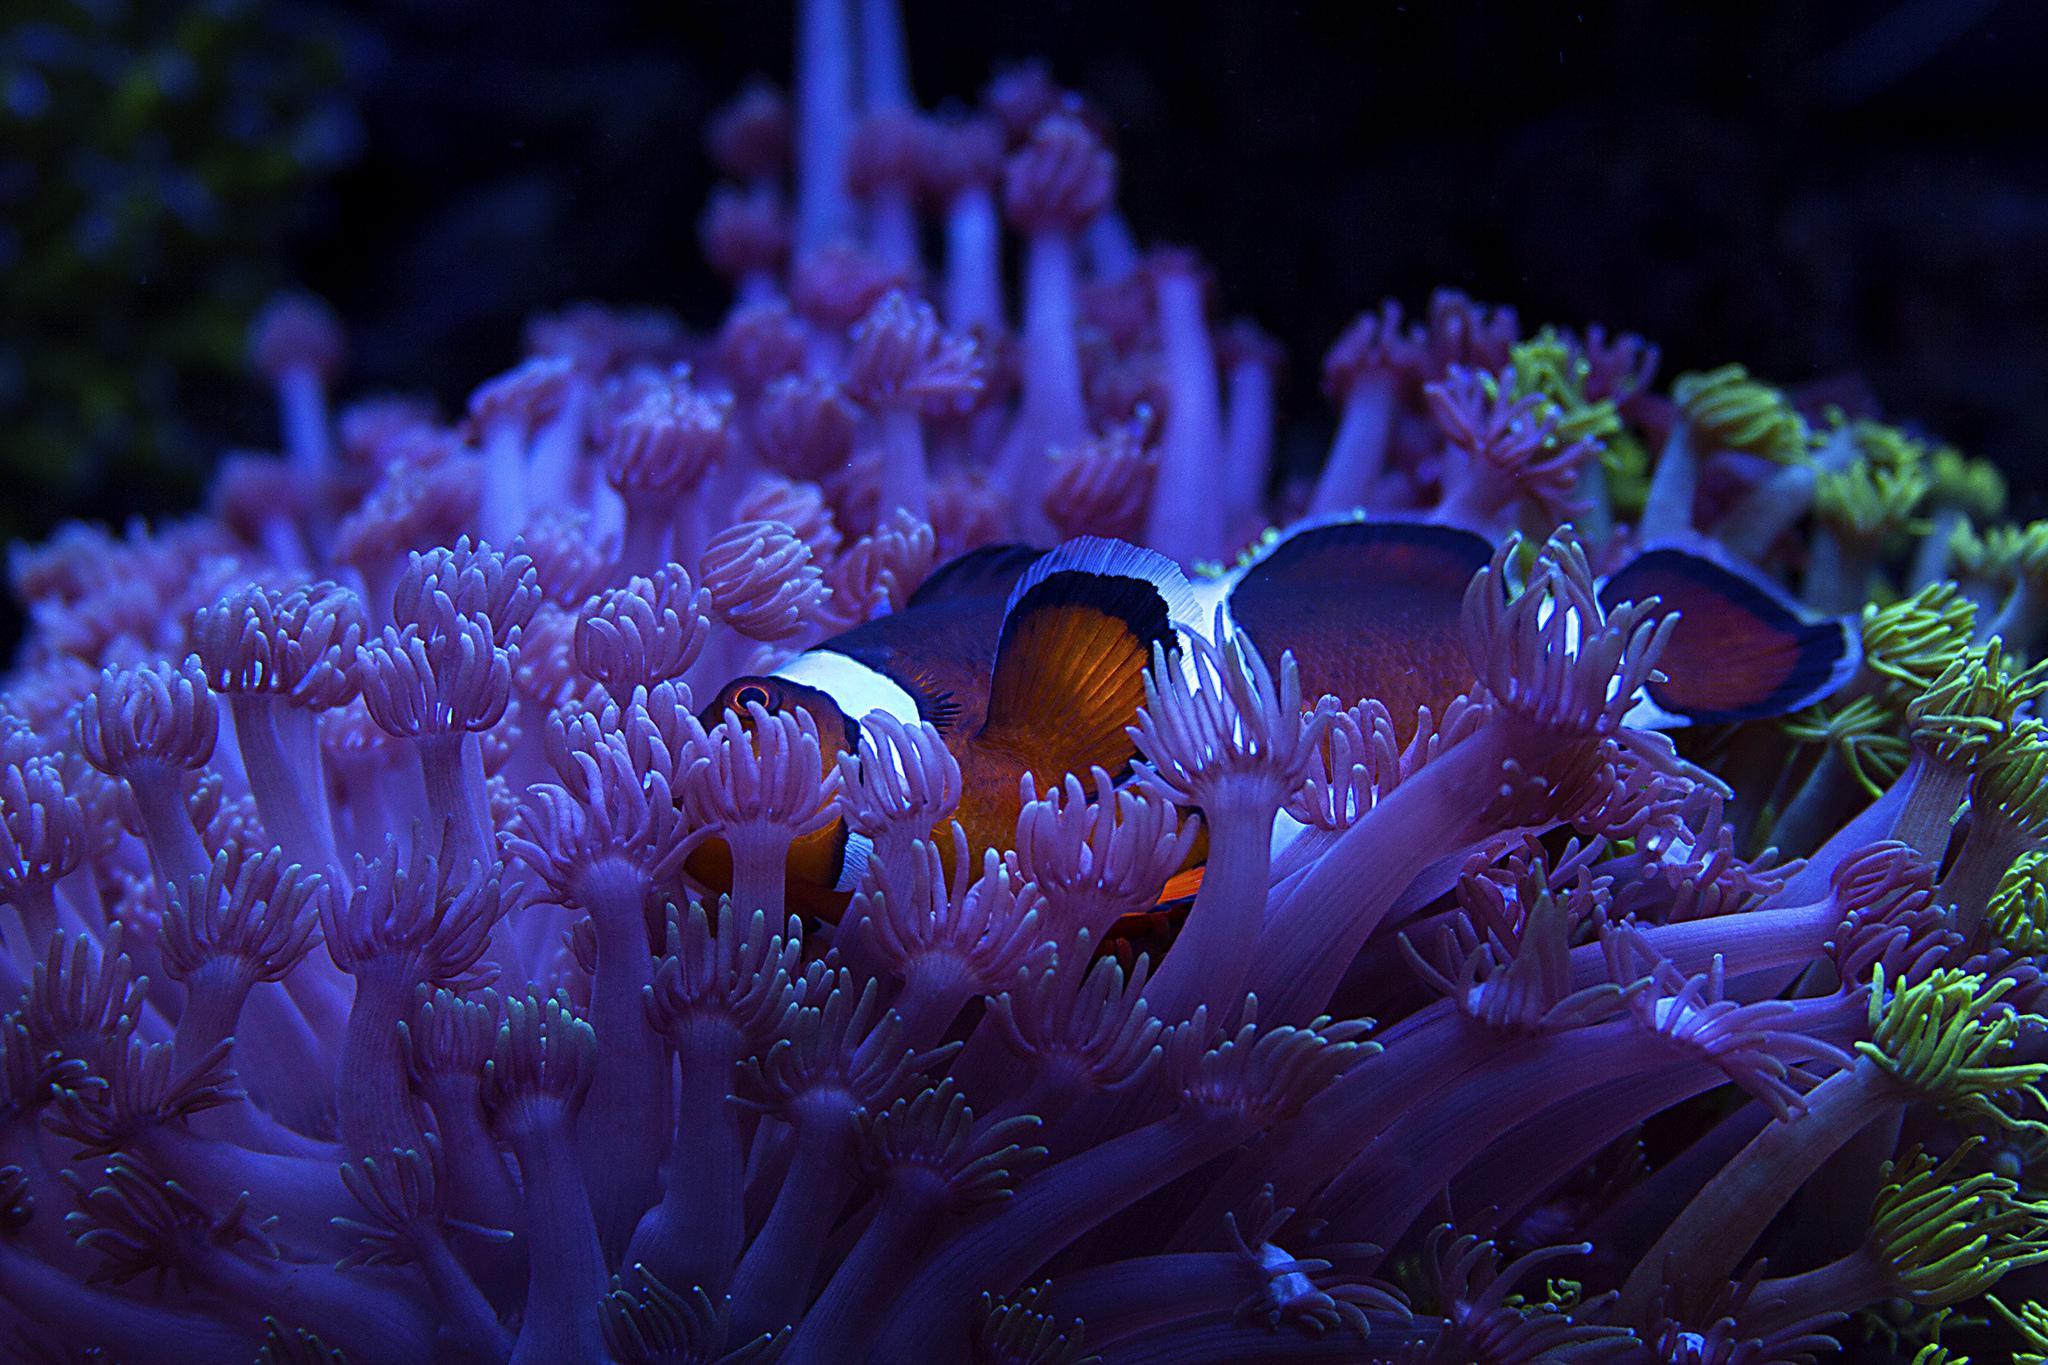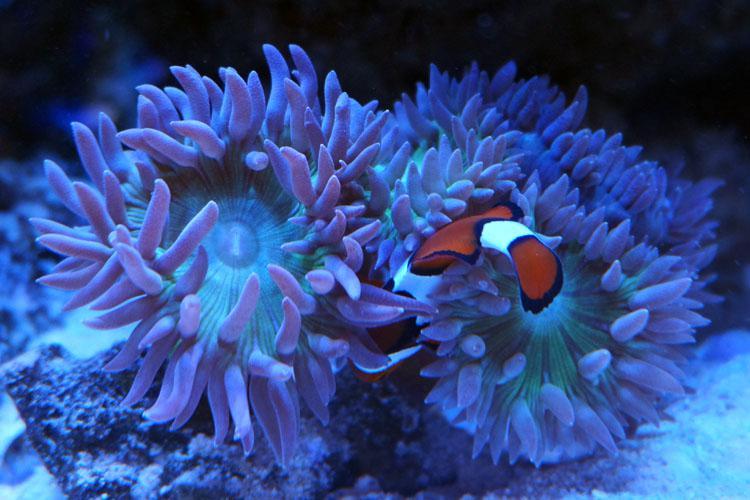The first image is the image on the left, the second image is the image on the right. Examine the images to the left and right. Is the description "A fish is swimming in the sea plant in both the images." accurate? Answer yes or no. Yes. The first image is the image on the left, the second image is the image on the right. For the images displayed, is the sentence "Each image shows at least one clown fish swimming among anemone." factually correct? Answer yes or no. Yes. 